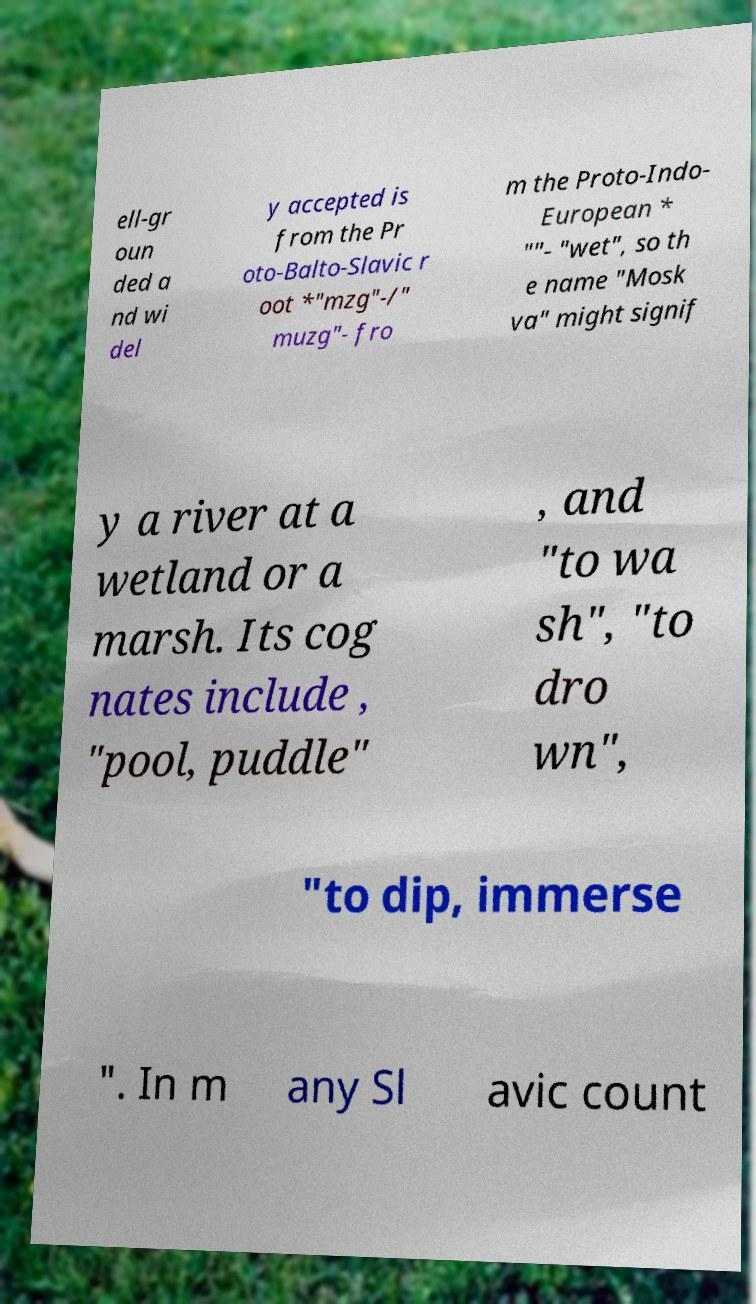I need the written content from this picture converted into text. Can you do that? ell-gr oun ded a nd wi del y accepted is from the Pr oto-Balto-Slavic r oot *"mzg"-/" muzg"- fro m the Proto-Indo- European * ""- "wet", so th e name "Mosk va" might signif y a river at a wetland or a marsh. Its cog nates include , "pool, puddle" , and "to wa sh", "to dro wn", "to dip, immerse ". In m any Sl avic count 